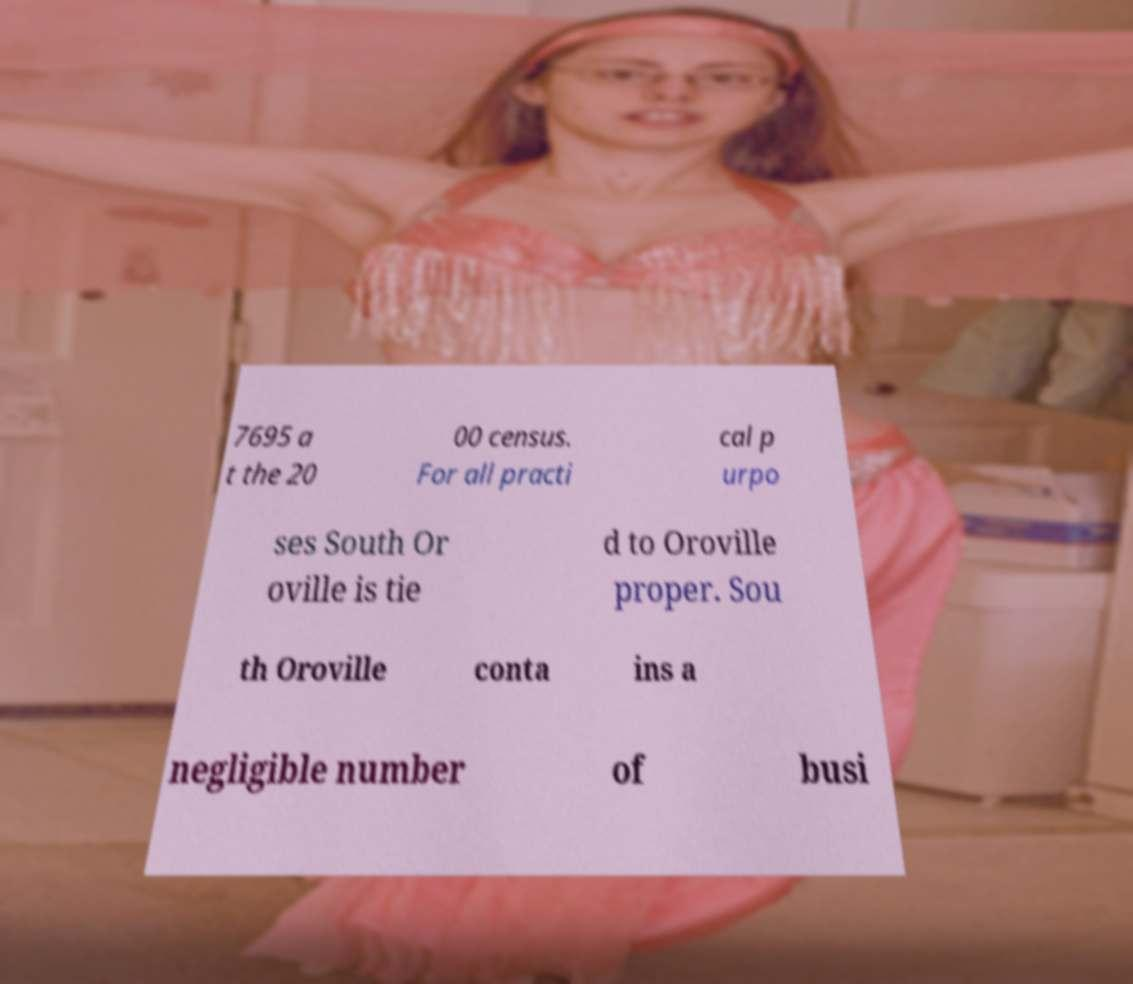There's text embedded in this image that I need extracted. Can you transcribe it verbatim? 7695 a t the 20 00 census. For all practi cal p urpo ses South Or oville is tie d to Oroville proper. Sou th Oroville conta ins a negligible number of busi 